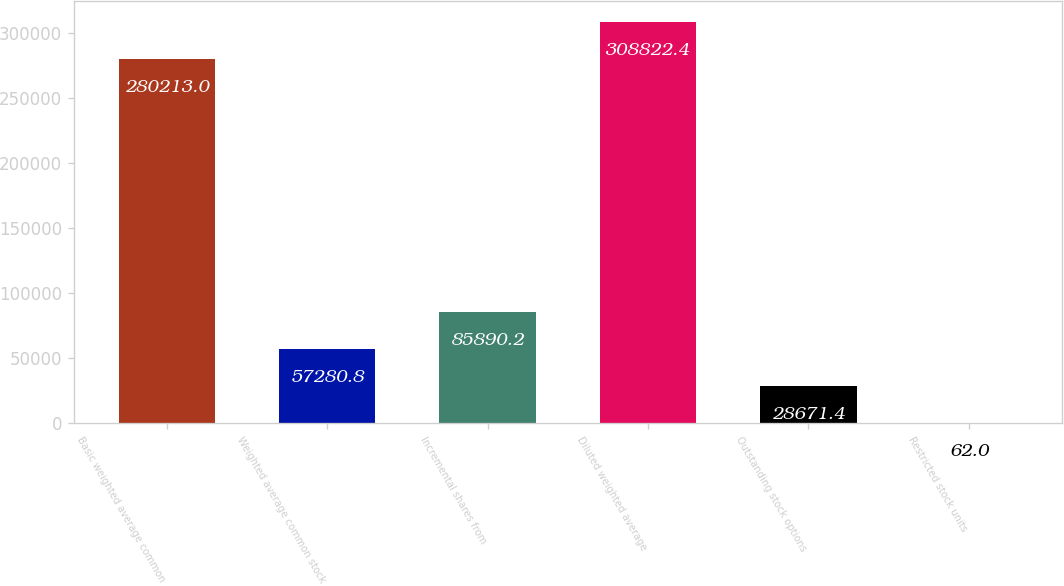Convert chart to OTSL. <chart><loc_0><loc_0><loc_500><loc_500><bar_chart><fcel>Basic weighted average common<fcel>Weighted average common stock<fcel>Incremental shares from<fcel>Diluted weighted average<fcel>Outstanding stock options<fcel>Restricted stock units<nl><fcel>280213<fcel>57280.8<fcel>85890.2<fcel>308822<fcel>28671.4<fcel>62<nl></chart> 